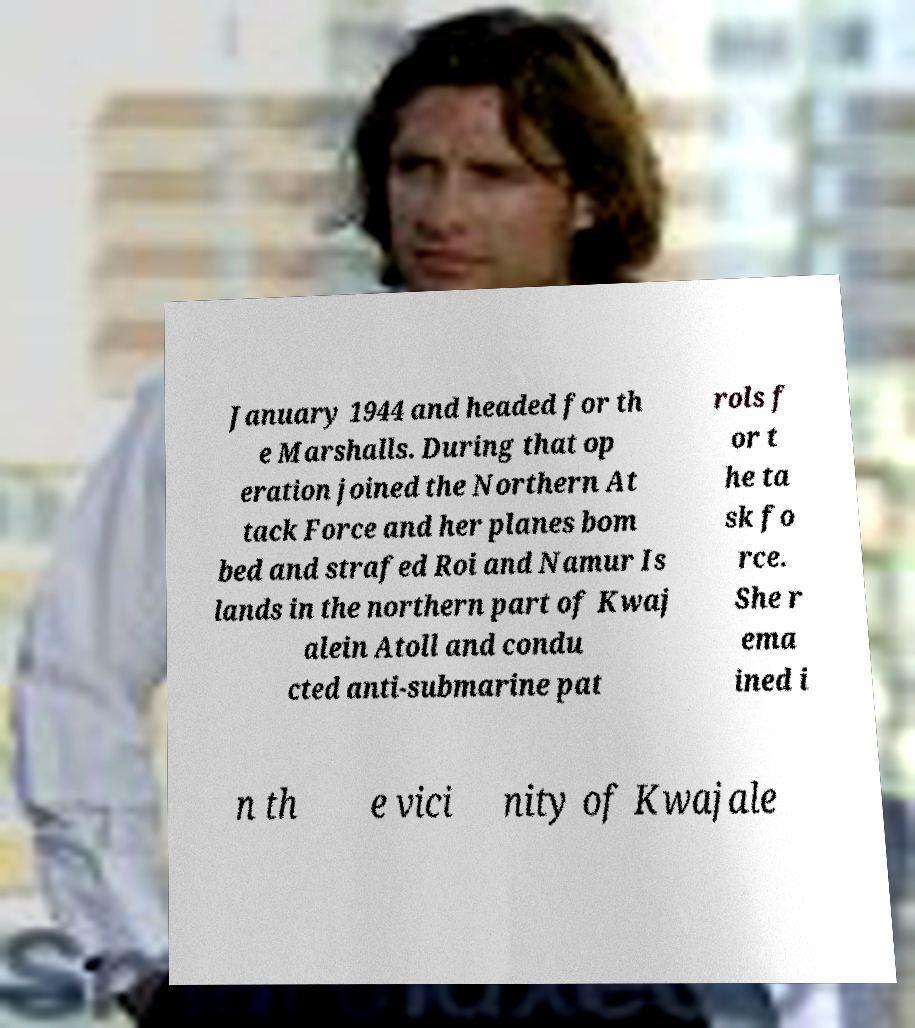Can you read and provide the text displayed in the image?This photo seems to have some interesting text. Can you extract and type it out for me? January 1944 and headed for th e Marshalls. During that op eration joined the Northern At tack Force and her planes bom bed and strafed Roi and Namur Is lands in the northern part of Kwaj alein Atoll and condu cted anti-submarine pat rols f or t he ta sk fo rce. She r ema ined i n th e vici nity of Kwajale 